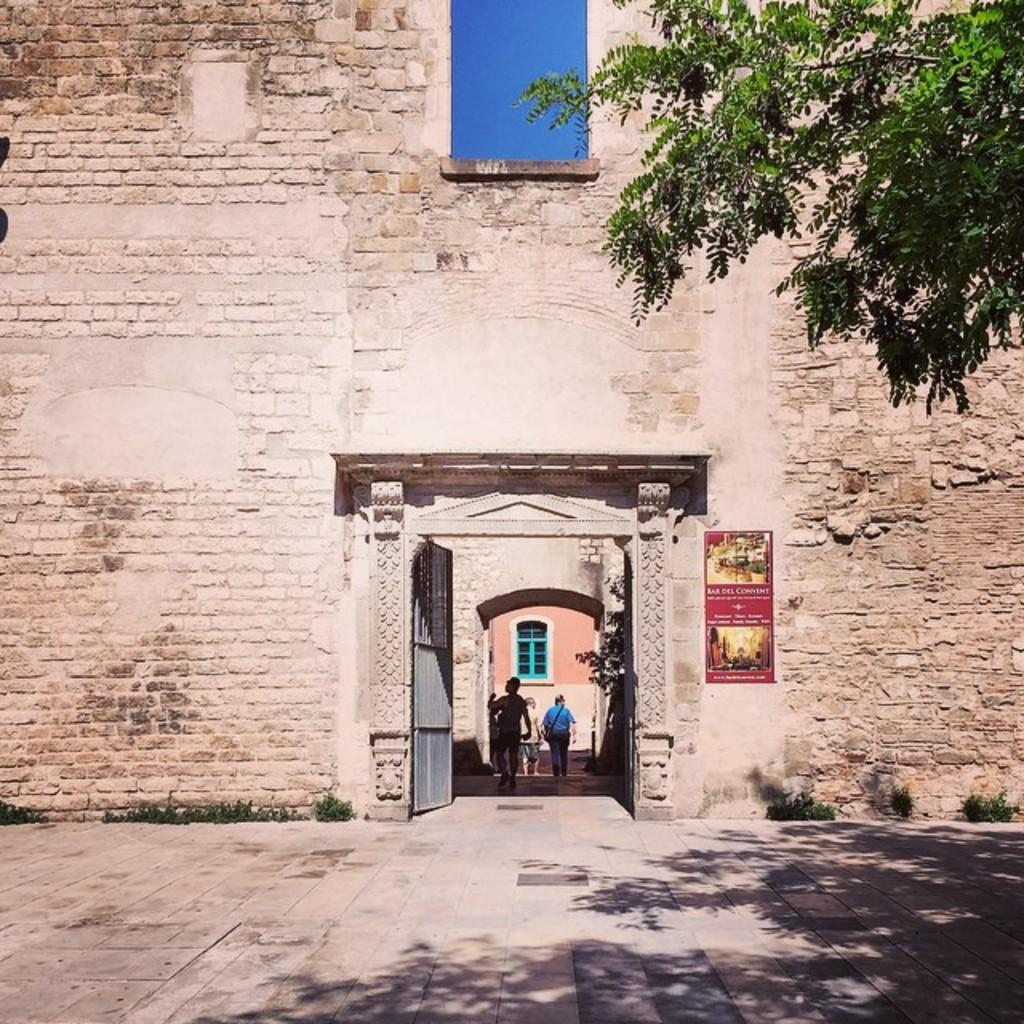What is on the wall in the image? There is a poster on the wall in the image. What type of natural element can be seen in the image? There is a tree visible in the image. Can you describe the people in the image? There are people in the distance in the image. What type of learning is taking place in the image? There is no indication of learning or any educational activity in the image. What is the relationship between the people in the image? The relationship between the people in the image cannot be determined from the image alone. 